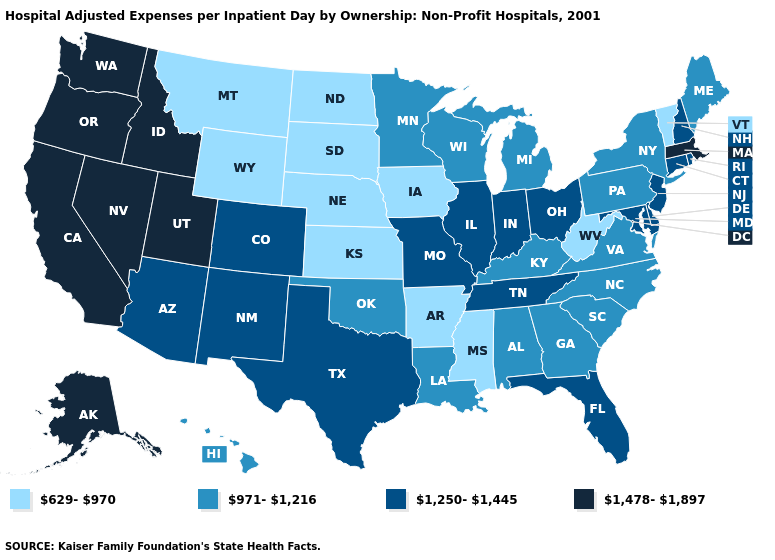Does Maine have the highest value in the Northeast?
Quick response, please. No. Which states have the lowest value in the South?
Answer briefly. Arkansas, Mississippi, West Virginia. Does South Dakota have the lowest value in the USA?
Write a very short answer. Yes. Name the states that have a value in the range 1,250-1,445?
Keep it brief. Arizona, Colorado, Connecticut, Delaware, Florida, Illinois, Indiana, Maryland, Missouri, New Hampshire, New Jersey, New Mexico, Ohio, Rhode Island, Tennessee, Texas. Which states have the highest value in the USA?
Concise answer only. Alaska, California, Idaho, Massachusetts, Nevada, Oregon, Utah, Washington. What is the highest value in states that border Louisiana?
Quick response, please. 1,250-1,445. What is the value of Indiana?
Give a very brief answer. 1,250-1,445. What is the lowest value in the MidWest?
Keep it brief. 629-970. What is the value of New Jersey?
Concise answer only. 1,250-1,445. How many symbols are there in the legend?
Concise answer only. 4. What is the value of Colorado?
Keep it brief. 1,250-1,445. How many symbols are there in the legend?
Keep it brief. 4. Which states hav the highest value in the MidWest?
Answer briefly. Illinois, Indiana, Missouri, Ohio. 